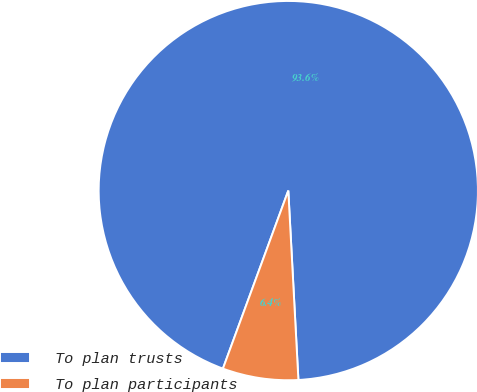Convert chart to OTSL. <chart><loc_0><loc_0><loc_500><loc_500><pie_chart><fcel>To plan trusts<fcel>To plan participants<nl><fcel>93.55%<fcel>6.45%<nl></chart> 